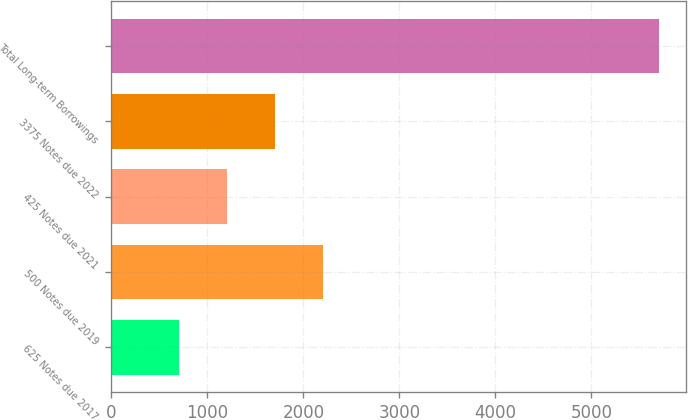Convert chart to OTSL. <chart><loc_0><loc_0><loc_500><loc_500><bar_chart><fcel>625 Notes due 2017<fcel>500 Notes due 2019<fcel>425 Notes due 2021<fcel>3375 Notes due 2022<fcel>Total Long-term Borrowings<nl><fcel>700<fcel>2200<fcel>1200<fcel>1700<fcel>5700<nl></chart> 